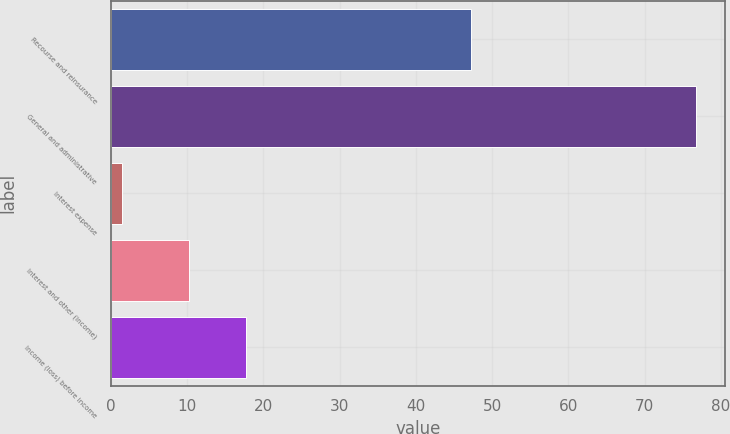Convert chart to OTSL. <chart><loc_0><loc_0><loc_500><loc_500><bar_chart><fcel>Recourse and reinsurance<fcel>General and administrative<fcel>Interest expense<fcel>Interest and other (income)<fcel>Income (loss) before income<nl><fcel>47.2<fcel>76.7<fcel>1.5<fcel>10.2<fcel>17.72<nl></chart> 